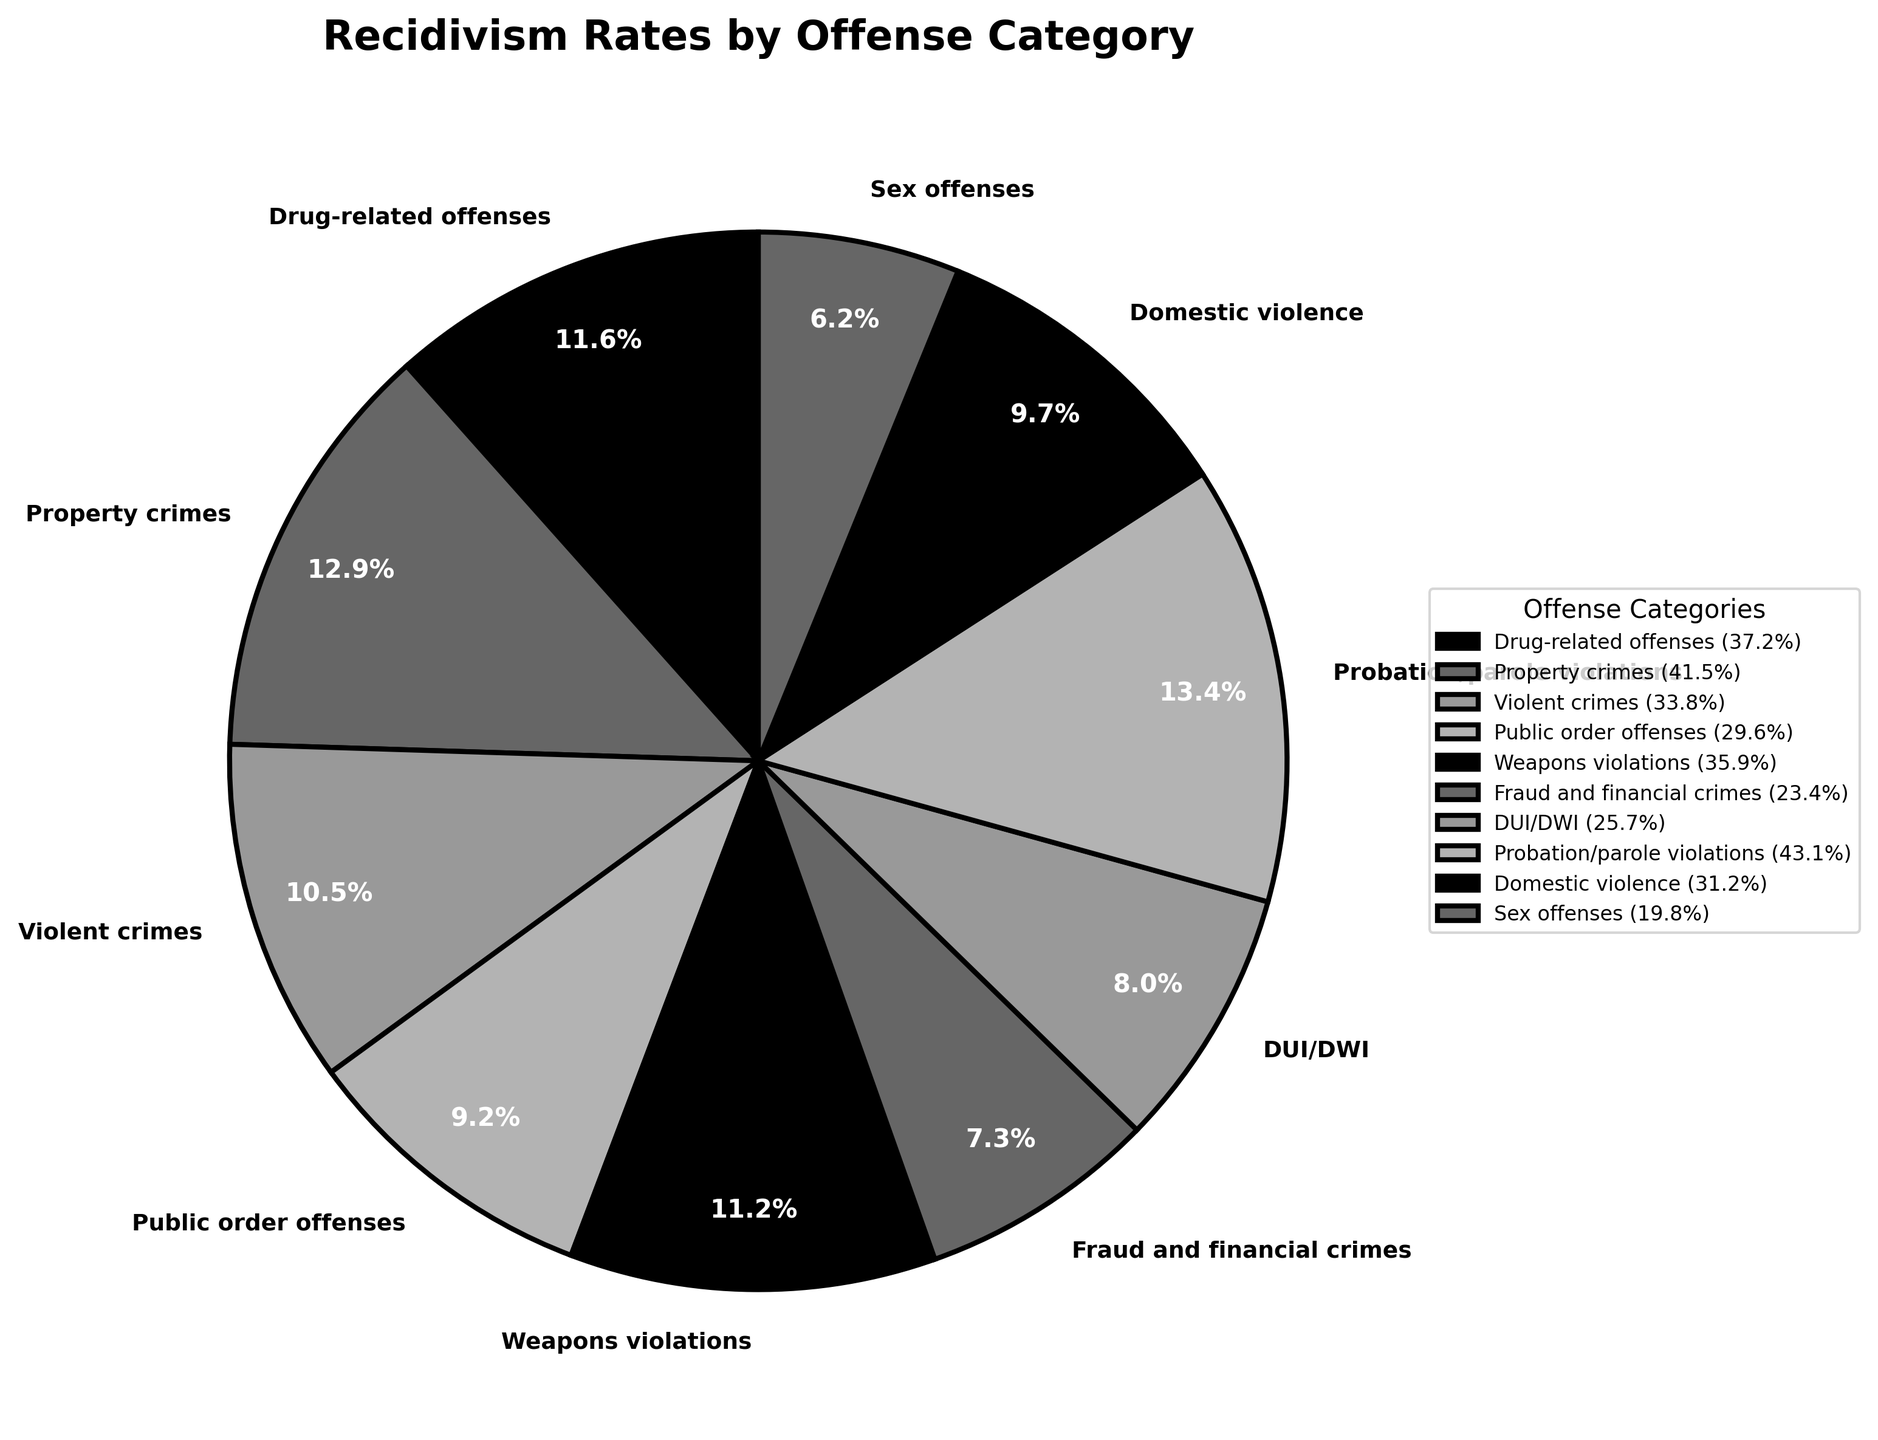What is the recidivism rate for Property crimes? The pie chart shows recidivism rates next to each offense category. Locate the label "Property crimes" and its corresponding value.
Answer: 41.5% Which offense category has the highest recidivism rate? Compare the recidivism rates of all categories displayed in the pie chart. Identify the highest value.
Answer: Probation/parole violations Which offense categories have a recidivism rate lower than 30%? Check the recidivism rates for all categories displayed in the pie chart and list those with rates below 30%.
Answer: Public order offenses, Fraud and financial crimes, DUI/DWI, Sex offenses What is the difference in recidivism rate between Drug-related offenses and Domestic violence? Find the recidivism rates for Drug-related offenses (37.2%) and Domestic violence (31.2%) and subtract the smaller from the larger.
Answer: 6.0% Sum up the recidivism rates for Public order offenses, DUI/DWI, and Weapons violations. Find the individual recidivism rates (Public order offenses: 29.6%, DUI/DWI: 25.7%, Weapons violations: 35.9%) and sum them up.
Answer: 91.2% How does the recidivism rate for Violent crimes compare to Sex offenses? Compare the recidivism rate for Violent crimes (33.8%) with that of Sex offenses (19.8%).
Answer: Higher Which offense category is the second highest in recidivism rate? Sort all the recidivism rates and identify the second highest. The highest is Probation/parole violations (43.1%), so the second highest is Property crimes (41.5%).
Answer: Property crimes What is the average recidivism rate across all offense categories shown? Sum up the recidivism rates for all categories and divide by the number of categories (10). The sum is (37.2 + 41.5 + 33.8 + 29.6 + 35.9 + 23.4 + 25.7 + 43.1 + 31.2 + 19.8) = 321.2, so the average is 321.2/10 = 32.12%.
Answer: 32.12% What is the recidivism rate for the category with the lowest rate? Find the lowest recidivism rate among all categories presented in the pie chart.
Answer: Sex offenses 